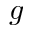Convert formula to latex. <formula><loc_0><loc_0><loc_500><loc_500>g</formula> 